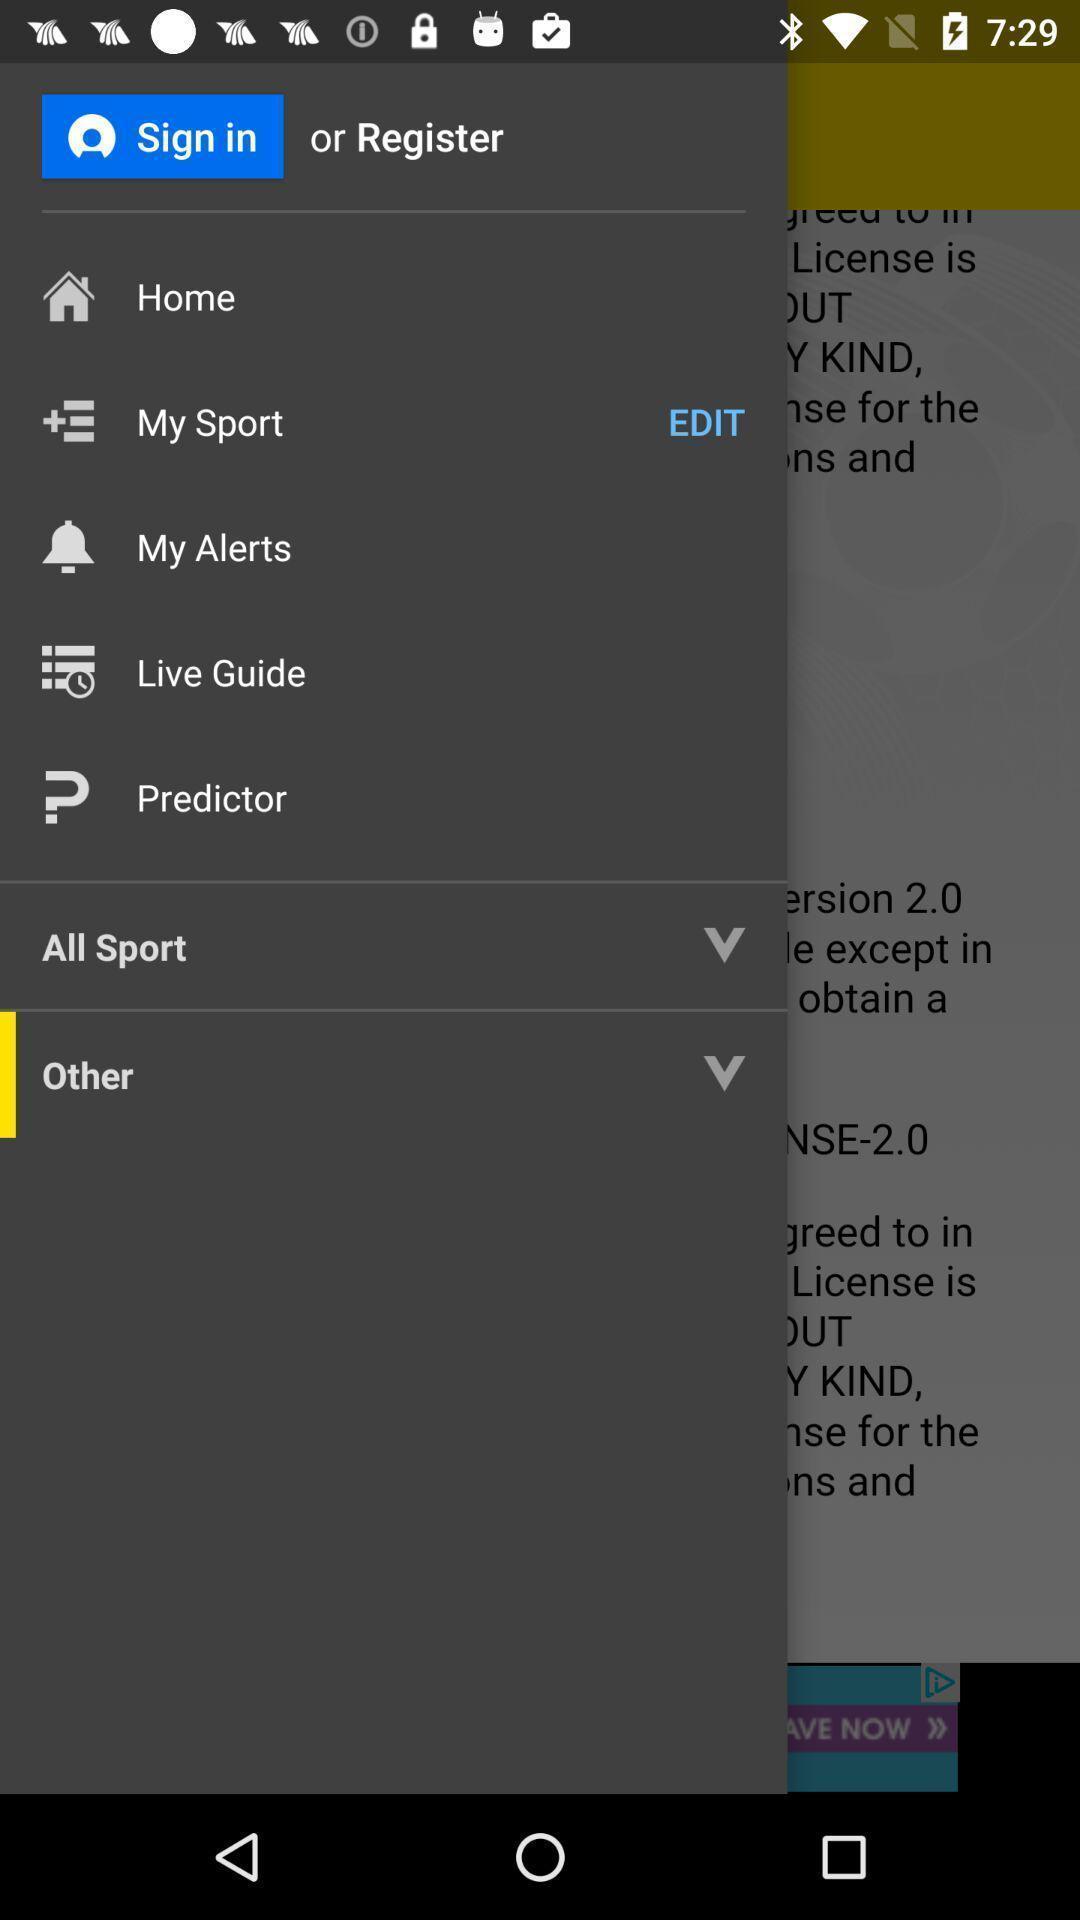Describe the visual elements of this screenshot. Sign-in or register page of a sports app. 